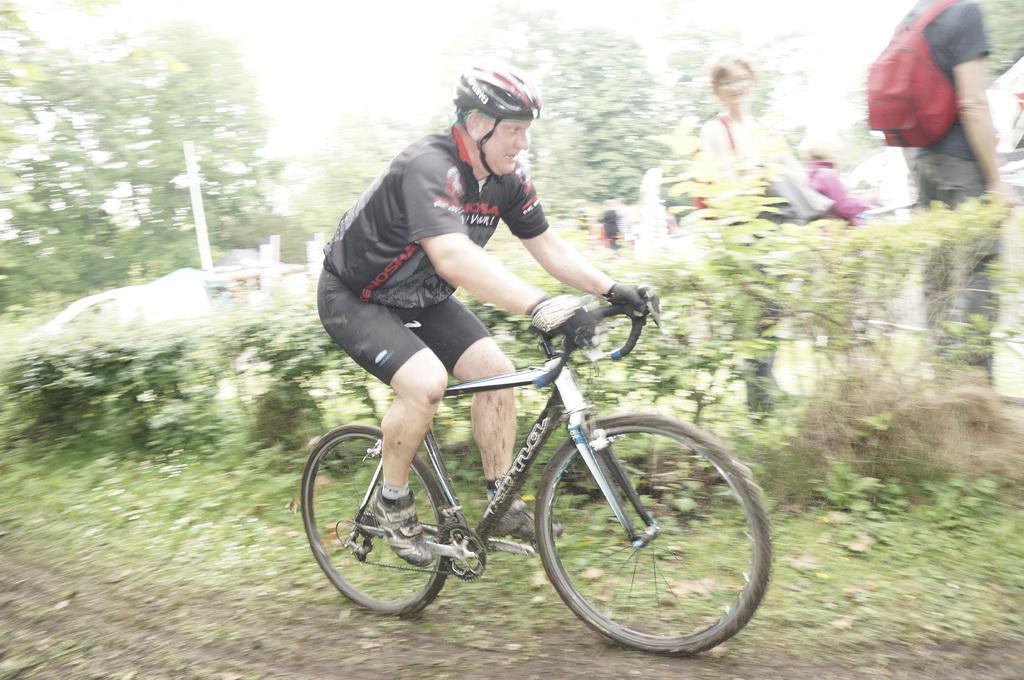How would you summarize this image in a sentence or two? Here is the old man wearing helmet and riding bicycle. There are two people standing. This is a red color backpack bag. These are the small bushes and these are the trees. I can see a pole here which is white in color. 